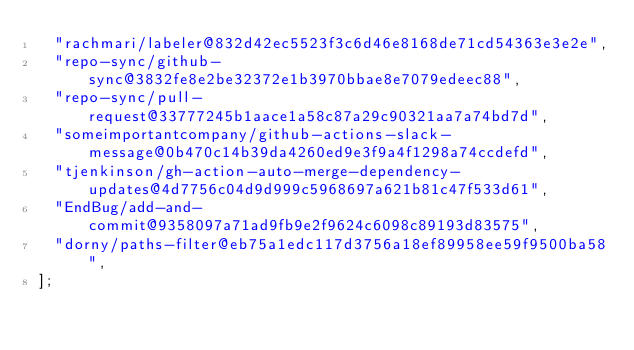Convert code to text. <code><loc_0><loc_0><loc_500><loc_500><_JavaScript_>  "rachmari/labeler@832d42ec5523f3c6d46e8168de71cd54363e3e2e",
  "repo-sync/github-sync@3832fe8e2be32372e1b3970bbae8e7079edeec88",
  "repo-sync/pull-request@33777245b1aace1a58c87a29c90321aa7a74bd7d",
  "someimportantcompany/github-actions-slack-message@0b470c14b39da4260ed9e3f9a4f1298a74ccdefd",
  "tjenkinson/gh-action-auto-merge-dependency-updates@4d7756c04d9d999c5968697a621b81c47f533d61",
  "EndBug/add-and-commit@9358097a71ad9fb9e2f9624c6098c89193d83575",
  "dorny/paths-filter@eb75a1edc117d3756a18ef89958ee59f9500ba58",
];
</code> 